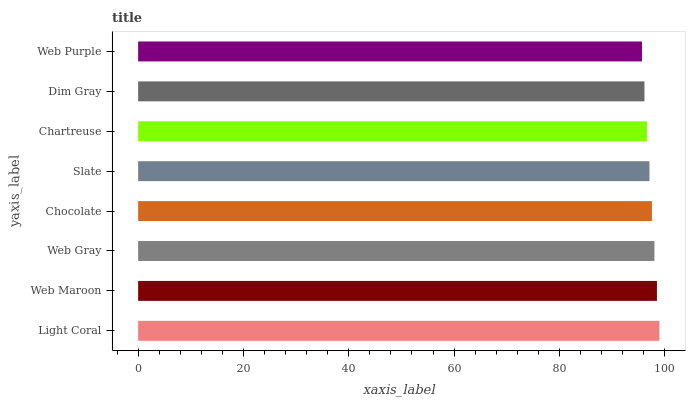Is Web Purple the minimum?
Answer yes or no. Yes. Is Light Coral the maximum?
Answer yes or no. Yes. Is Web Maroon the minimum?
Answer yes or no. No. Is Web Maroon the maximum?
Answer yes or no. No. Is Light Coral greater than Web Maroon?
Answer yes or no. Yes. Is Web Maroon less than Light Coral?
Answer yes or no. Yes. Is Web Maroon greater than Light Coral?
Answer yes or no. No. Is Light Coral less than Web Maroon?
Answer yes or no. No. Is Chocolate the high median?
Answer yes or no. Yes. Is Slate the low median?
Answer yes or no. Yes. Is Slate the high median?
Answer yes or no. No. Is Web Gray the low median?
Answer yes or no. No. 